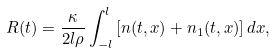<formula> <loc_0><loc_0><loc_500><loc_500>R ( t ) = \frac { \kappa } { 2 l \rho } \int _ { - l } ^ { l } \left [ n ( t , x ) + n _ { 1 } ( t , x ) \right ] d x ,</formula> 